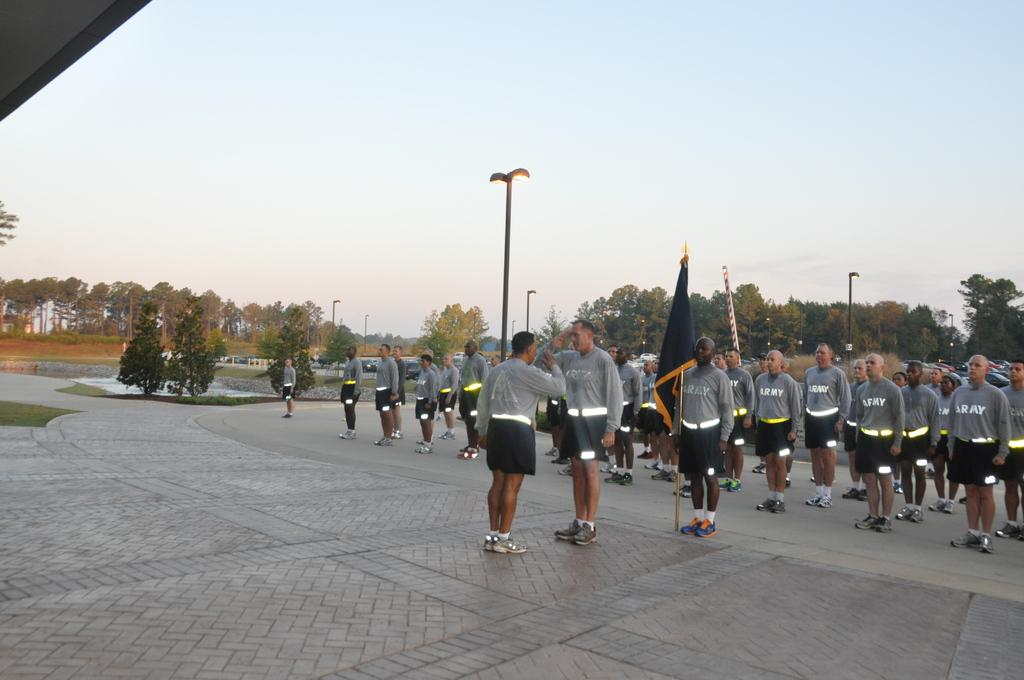How many people are present in the image? There are many people standing in the image. What is one person holding in the image? One person is holding a flag with a pole. What else can be seen in the image besides people? There are poles in the image. What can be seen in the background of the image? Trees and the sky are visible in the background of the image. Where are the beds located in the image? There are no beds present in the image. What type of dust can be seen in the image? There is no dust visible in the image. 